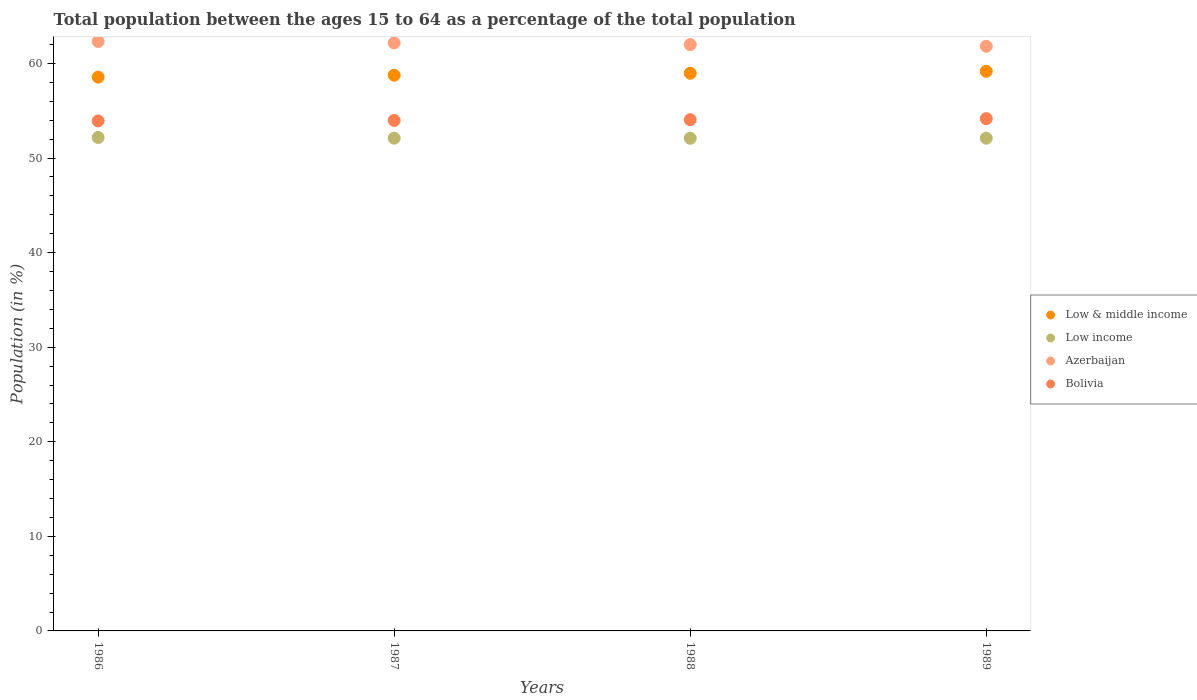How many different coloured dotlines are there?
Keep it short and to the point. 4. What is the percentage of the population ages 15 to 64 in Low income in 1987?
Offer a very short reply. 52.11. Across all years, what is the maximum percentage of the population ages 15 to 64 in Low income?
Provide a short and direct response. 52.18. Across all years, what is the minimum percentage of the population ages 15 to 64 in Azerbaijan?
Give a very brief answer. 61.82. What is the total percentage of the population ages 15 to 64 in Bolivia in the graph?
Provide a short and direct response. 216.13. What is the difference between the percentage of the population ages 15 to 64 in Low income in 1987 and that in 1989?
Provide a short and direct response. 0. What is the difference between the percentage of the population ages 15 to 64 in Low income in 1988 and the percentage of the population ages 15 to 64 in Azerbaijan in 1989?
Offer a very short reply. -9.73. What is the average percentage of the population ages 15 to 64 in Low income per year?
Provide a succinct answer. 52.12. In the year 1986, what is the difference between the percentage of the population ages 15 to 64 in Low income and percentage of the population ages 15 to 64 in Bolivia?
Your answer should be very brief. -1.75. What is the ratio of the percentage of the population ages 15 to 64 in Azerbaijan in 1986 to that in 1989?
Provide a succinct answer. 1.01. Is the percentage of the population ages 15 to 64 in Low income in 1986 less than that in 1989?
Give a very brief answer. No. Is the difference between the percentage of the population ages 15 to 64 in Low income in 1986 and 1988 greater than the difference between the percentage of the population ages 15 to 64 in Bolivia in 1986 and 1988?
Provide a short and direct response. Yes. What is the difference between the highest and the second highest percentage of the population ages 15 to 64 in Azerbaijan?
Give a very brief answer. 0.16. What is the difference between the highest and the lowest percentage of the population ages 15 to 64 in Bolivia?
Your response must be concise. 0.24. In how many years, is the percentage of the population ages 15 to 64 in Azerbaijan greater than the average percentage of the population ages 15 to 64 in Azerbaijan taken over all years?
Your response must be concise. 2. Does the percentage of the population ages 15 to 64 in Bolivia monotonically increase over the years?
Offer a terse response. Yes. Is the percentage of the population ages 15 to 64 in Azerbaijan strictly less than the percentage of the population ages 15 to 64 in Low income over the years?
Offer a terse response. No. How many dotlines are there?
Your answer should be very brief. 4. What is the difference between two consecutive major ticks on the Y-axis?
Keep it short and to the point. 10. How are the legend labels stacked?
Provide a succinct answer. Vertical. What is the title of the graph?
Your answer should be compact. Total population between the ages 15 to 64 as a percentage of the total population. Does "Slovak Republic" appear as one of the legend labels in the graph?
Provide a short and direct response. No. What is the Population (in %) of Low & middle income in 1986?
Provide a succinct answer. 58.56. What is the Population (in %) of Low income in 1986?
Your answer should be compact. 52.18. What is the Population (in %) of Azerbaijan in 1986?
Your answer should be compact. 62.33. What is the Population (in %) of Bolivia in 1986?
Your answer should be compact. 53.93. What is the Population (in %) of Low & middle income in 1987?
Ensure brevity in your answer.  58.76. What is the Population (in %) in Low income in 1987?
Offer a very short reply. 52.11. What is the Population (in %) of Azerbaijan in 1987?
Offer a terse response. 62.18. What is the Population (in %) in Bolivia in 1987?
Provide a succinct answer. 53.98. What is the Population (in %) in Low & middle income in 1988?
Make the answer very short. 58.97. What is the Population (in %) of Low income in 1988?
Give a very brief answer. 52.1. What is the Population (in %) in Azerbaijan in 1988?
Give a very brief answer. 62. What is the Population (in %) of Bolivia in 1988?
Provide a short and direct response. 54.06. What is the Population (in %) in Low & middle income in 1989?
Ensure brevity in your answer.  59.17. What is the Population (in %) of Low income in 1989?
Your answer should be compact. 52.1. What is the Population (in %) in Azerbaijan in 1989?
Your answer should be compact. 61.82. What is the Population (in %) of Bolivia in 1989?
Your answer should be very brief. 54.17. Across all years, what is the maximum Population (in %) in Low & middle income?
Provide a succinct answer. 59.17. Across all years, what is the maximum Population (in %) in Low income?
Your answer should be very brief. 52.18. Across all years, what is the maximum Population (in %) in Azerbaijan?
Make the answer very short. 62.33. Across all years, what is the maximum Population (in %) of Bolivia?
Keep it short and to the point. 54.17. Across all years, what is the minimum Population (in %) in Low & middle income?
Offer a terse response. 58.56. Across all years, what is the minimum Population (in %) in Low income?
Your answer should be very brief. 52.1. Across all years, what is the minimum Population (in %) of Azerbaijan?
Keep it short and to the point. 61.82. Across all years, what is the minimum Population (in %) of Bolivia?
Make the answer very short. 53.93. What is the total Population (in %) in Low & middle income in the graph?
Provide a short and direct response. 235.46. What is the total Population (in %) of Low income in the graph?
Ensure brevity in your answer.  208.48. What is the total Population (in %) of Azerbaijan in the graph?
Offer a very short reply. 248.34. What is the total Population (in %) in Bolivia in the graph?
Your answer should be compact. 216.13. What is the difference between the Population (in %) of Low & middle income in 1986 and that in 1987?
Keep it short and to the point. -0.2. What is the difference between the Population (in %) in Low income in 1986 and that in 1987?
Offer a very short reply. 0.07. What is the difference between the Population (in %) in Azerbaijan in 1986 and that in 1987?
Offer a terse response. 0.16. What is the difference between the Population (in %) of Bolivia in 1986 and that in 1987?
Make the answer very short. -0.05. What is the difference between the Population (in %) in Low & middle income in 1986 and that in 1988?
Offer a very short reply. -0.41. What is the difference between the Population (in %) of Low income in 1986 and that in 1988?
Offer a very short reply. 0.08. What is the difference between the Population (in %) in Azerbaijan in 1986 and that in 1988?
Keep it short and to the point. 0.33. What is the difference between the Population (in %) of Bolivia in 1986 and that in 1988?
Make the answer very short. -0.13. What is the difference between the Population (in %) in Low & middle income in 1986 and that in 1989?
Make the answer very short. -0.62. What is the difference between the Population (in %) of Low income in 1986 and that in 1989?
Ensure brevity in your answer.  0.07. What is the difference between the Population (in %) of Azerbaijan in 1986 and that in 1989?
Keep it short and to the point. 0.51. What is the difference between the Population (in %) in Bolivia in 1986 and that in 1989?
Make the answer very short. -0.24. What is the difference between the Population (in %) of Low & middle income in 1987 and that in 1988?
Keep it short and to the point. -0.21. What is the difference between the Population (in %) in Low income in 1987 and that in 1988?
Your answer should be compact. 0.01. What is the difference between the Population (in %) in Azerbaijan in 1987 and that in 1988?
Make the answer very short. 0.18. What is the difference between the Population (in %) of Bolivia in 1987 and that in 1988?
Offer a very short reply. -0.08. What is the difference between the Population (in %) in Low & middle income in 1987 and that in 1989?
Give a very brief answer. -0.41. What is the difference between the Population (in %) in Low income in 1987 and that in 1989?
Offer a terse response. 0. What is the difference between the Population (in %) of Azerbaijan in 1987 and that in 1989?
Keep it short and to the point. 0.36. What is the difference between the Population (in %) of Bolivia in 1987 and that in 1989?
Your answer should be very brief. -0.19. What is the difference between the Population (in %) in Low & middle income in 1988 and that in 1989?
Your answer should be very brief. -0.21. What is the difference between the Population (in %) of Low income in 1988 and that in 1989?
Offer a very short reply. -0.01. What is the difference between the Population (in %) in Azerbaijan in 1988 and that in 1989?
Ensure brevity in your answer.  0.18. What is the difference between the Population (in %) in Bolivia in 1988 and that in 1989?
Your answer should be compact. -0.11. What is the difference between the Population (in %) in Low & middle income in 1986 and the Population (in %) in Low income in 1987?
Make the answer very short. 6.45. What is the difference between the Population (in %) in Low & middle income in 1986 and the Population (in %) in Azerbaijan in 1987?
Provide a succinct answer. -3.62. What is the difference between the Population (in %) of Low & middle income in 1986 and the Population (in %) of Bolivia in 1987?
Your answer should be very brief. 4.58. What is the difference between the Population (in %) of Low income in 1986 and the Population (in %) of Azerbaijan in 1987?
Your response must be concise. -10. What is the difference between the Population (in %) in Low income in 1986 and the Population (in %) in Bolivia in 1987?
Your answer should be very brief. -1.8. What is the difference between the Population (in %) of Azerbaijan in 1986 and the Population (in %) of Bolivia in 1987?
Make the answer very short. 8.36. What is the difference between the Population (in %) in Low & middle income in 1986 and the Population (in %) in Low income in 1988?
Give a very brief answer. 6.46. What is the difference between the Population (in %) of Low & middle income in 1986 and the Population (in %) of Azerbaijan in 1988?
Make the answer very short. -3.44. What is the difference between the Population (in %) of Low & middle income in 1986 and the Population (in %) of Bolivia in 1988?
Provide a succinct answer. 4.5. What is the difference between the Population (in %) of Low income in 1986 and the Population (in %) of Azerbaijan in 1988?
Your response must be concise. -9.82. What is the difference between the Population (in %) in Low income in 1986 and the Population (in %) in Bolivia in 1988?
Give a very brief answer. -1.88. What is the difference between the Population (in %) of Azerbaijan in 1986 and the Population (in %) of Bolivia in 1988?
Provide a succinct answer. 8.27. What is the difference between the Population (in %) of Low & middle income in 1986 and the Population (in %) of Low income in 1989?
Your answer should be very brief. 6.45. What is the difference between the Population (in %) in Low & middle income in 1986 and the Population (in %) in Azerbaijan in 1989?
Your answer should be compact. -3.26. What is the difference between the Population (in %) of Low & middle income in 1986 and the Population (in %) of Bolivia in 1989?
Your answer should be very brief. 4.39. What is the difference between the Population (in %) of Low income in 1986 and the Population (in %) of Azerbaijan in 1989?
Ensure brevity in your answer.  -9.64. What is the difference between the Population (in %) in Low income in 1986 and the Population (in %) in Bolivia in 1989?
Provide a short and direct response. -1.99. What is the difference between the Population (in %) of Azerbaijan in 1986 and the Population (in %) of Bolivia in 1989?
Give a very brief answer. 8.17. What is the difference between the Population (in %) in Low & middle income in 1987 and the Population (in %) in Low income in 1988?
Offer a very short reply. 6.67. What is the difference between the Population (in %) in Low & middle income in 1987 and the Population (in %) in Azerbaijan in 1988?
Keep it short and to the point. -3.24. What is the difference between the Population (in %) in Low & middle income in 1987 and the Population (in %) in Bolivia in 1988?
Provide a succinct answer. 4.7. What is the difference between the Population (in %) in Low income in 1987 and the Population (in %) in Azerbaijan in 1988?
Your answer should be compact. -9.9. What is the difference between the Population (in %) of Low income in 1987 and the Population (in %) of Bolivia in 1988?
Offer a terse response. -1.96. What is the difference between the Population (in %) of Azerbaijan in 1987 and the Population (in %) of Bolivia in 1988?
Offer a very short reply. 8.12. What is the difference between the Population (in %) of Low & middle income in 1987 and the Population (in %) of Low income in 1989?
Your answer should be compact. 6.66. What is the difference between the Population (in %) of Low & middle income in 1987 and the Population (in %) of Azerbaijan in 1989?
Make the answer very short. -3.06. What is the difference between the Population (in %) in Low & middle income in 1987 and the Population (in %) in Bolivia in 1989?
Your response must be concise. 4.59. What is the difference between the Population (in %) in Low income in 1987 and the Population (in %) in Azerbaijan in 1989?
Your answer should be very brief. -9.72. What is the difference between the Population (in %) in Low income in 1987 and the Population (in %) in Bolivia in 1989?
Offer a terse response. -2.06. What is the difference between the Population (in %) of Azerbaijan in 1987 and the Population (in %) of Bolivia in 1989?
Make the answer very short. 8.01. What is the difference between the Population (in %) in Low & middle income in 1988 and the Population (in %) in Low income in 1989?
Your answer should be compact. 6.86. What is the difference between the Population (in %) of Low & middle income in 1988 and the Population (in %) of Azerbaijan in 1989?
Your answer should be very brief. -2.85. What is the difference between the Population (in %) of Low & middle income in 1988 and the Population (in %) of Bolivia in 1989?
Your answer should be very brief. 4.8. What is the difference between the Population (in %) of Low income in 1988 and the Population (in %) of Azerbaijan in 1989?
Your response must be concise. -9.73. What is the difference between the Population (in %) of Low income in 1988 and the Population (in %) of Bolivia in 1989?
Ensure brevity in your answer.  -2.07. What is the difference between the Population (in %) of Azerbaijan in 1988 and the Population (in %) of Bolivia in 1989?
Ensure brevity in your answer.  7.83. What is the average Population (in %) of Low & middle income per year?
Give a very brief answer. 58.87. What is the average Population (in %) of Low income per year?
Provide a succinct answer. 52.12. What is the average Population (in %) in Azerbaijan per year?
Provide a short and direct response. 62.08. What is the average Population (in %) in Bolivia per year?
Offer a terse response. 54.03. In the year 1986, what is the difference between the Population (in %) of Low & middle income and Population (in %) of Low income?
Keep it short and to the point. 6.38. In the year 1986, what is the difference between the Population (in %) of Low & middle income and Population (in %) of Azerbaijan?
Offer a very short reply. -3.78. In the year 1986, what is the difference between the Population (in %) of Low & middle income and Population (in %) of Bolivia?
Give a very brief answer. 4.63. In the year 1986, what is the difference between the Population (in %) in Low income and Population (in %) in Azerbaijan?
Give a very brief answer. -10.16. In the year 1986, what is the difference between the Population (in %) of Low income and Population (in %) of Bolivia?
Keep it short and to the point. -1.75. In the year 1986, what is the difference between the Population (in %) in Azerbaijan and Population (in %) in Bolivia?
Your answer should be compact. 8.41. In the year 1987, what is the difference between the Population (in %) of Low & middle income and Population (in %) of Low income?
Offer a terse response. 6.66. In the year 1987, what is the difference between the Population (in %) in Low & middle income and Population (in %) in Azerbaijan?
Ensure brevity in your answer.  -3.42. In the year 1987, what is the difference between the Population (in %) of Low & middle income and Population (in %) of Bolivia?
Your response must be concise. 4.78. In the year 1987, what is the difference between the Population (in %) in Low income and Population (in %) in Azerbaijan?
Give a very brief answer. -10.07. In the year 1987, what is the difference between the Population (in %) of Low income and Population (in %) of Bolivia?
Offer a terse response. -1.87. In the year 1987, what is the difference between the Population (in %) of Azerbaijan and Population (in %) of Bolivia?
Your answer should be compact. 8.2. In the year 1988, what is the difference between the Population (in %) of Low & middle income and Population (in %) of Low income?
Offer a very short reply. 6.87. In the year 1988, what is the difference between the Population (in %) in Low & middle income and Population (in %) in Azerbaijan?
Offer a very short reply. -3.03. In the year 1988, what is the difference between the Population (in %) of Low & middle income and Population (in %) of Bolivia?
Your answer should be very brief. 4.91. In the year 1988, what is the difference between the Population (in %) in Low income and Population (in %) in Azerbaijan?
Provide a succinct answer. -9.91. In the year 1988, what is the difference between the Population (in %) of Low income and Population (in %) of Bolivia?
Keep it short and to the point. -1.96. In the year 1988, what is the difference between the Population (in %) of Azerbaijan and Population (in %) of Bolivia?
Offer a very short reply. 7.94. In the year 1989, what is the difference between the Population (in %) in Low & middle income and Population (in %) in Low income?
Provide a short and direct response. 7.07. In the year 1989, what is the difference between the Population (in %) of Low & middle income and Population (in %) of Azerbaijan?
Provide a short and direct response. -2.65. In the year 1989, what is the difference between the Population (in %) of Low & middle income and Population (in %) of Bolivia?
Make the answer very short. 5.01. In the year 1989, what is the difference between the Population (in %) of Low income and Population (in %) of Azerbaijan?
Your answer should be very brief. -9.72. In the year 1989, what is the difference between the Population (in %) of Low income and Population (in %) of Bolivia?
Offer a very short reply. -2.06. In the year 1989, what is the difference between the Population (in %) of Azerbaijan and Population (in %) of Bolivia?
Ensure brevity in your answer.  7.65. What is the ratio of the Population (in %) of Low & middle income in 1986 to that in 1987?
Ensure brevity in your answer.  1. What is the ratio of the Population (in %) in Bolivia in 1986 to that in 1987?
Your answer should be compact. 1. What is the ratio of the Population (in %) of Low & middle income in 1986 to that in 1988?
Offer a very short reply. 0.99. What is the ratio of the Population (in %) of Azerbaijan in 1986 to that in 1988?
Provide a succinct answer. 1.01. What is the ratio of the Population (in %) of Bolivia in 1986 to that in 1988?
Your answer should be compact. 1. What is the ratio of the Population (in %) in Low & middle income in 1986 to that in 1989?
Offer a very short reply. 0.99. What is the ratio of the Population (in %) in Azerbaijan in 1986 to that in 1989?
Offer a terse response. 1.01. What is the ratio of the Population (in %) in Bolivia in 1986 to that in 1989?
Your response must be concise. 1. What is the ratio of the Population (in %) in Azerbaijan in 1987 to that in 1988?
Give a very brief answer. 1. What is the ratio of the Population (in %) in Low income in 1987 to that in 1989?
Make the answer very short. 1. What is the difference between the highest and the second highest Population (in %) of Low & middle income?
Ensure brevity in your answer.  0.21. What is the difference between the highest and the second highest Population (in %) of Low income?
Provide a succinct answer. 0.07. What is the difference between the highest and the second highest Population (in %) of Azerbaijan?
Provide a short and direct response. 0.16. What is the difference between the highest and the second highest Population (in %) of Bolivia?
Ensure brevity in your answer.  0.11. What is the difference between the highest and the lowest Population (in %) of Low & middle income?
Keep it short and to the point. 0.62. What is the difference between the highest and the lowest Population (in %) of Low income?
Make the answer very short. 0.08. What is the difference between the highest and the lowest Population (in %) in Azerbaijan?
Give a very brief answer. 0.51. What is the difference between the highest and the lowest Population (in %) of Bolivia?
Keep it short and to the point. 0.24. 